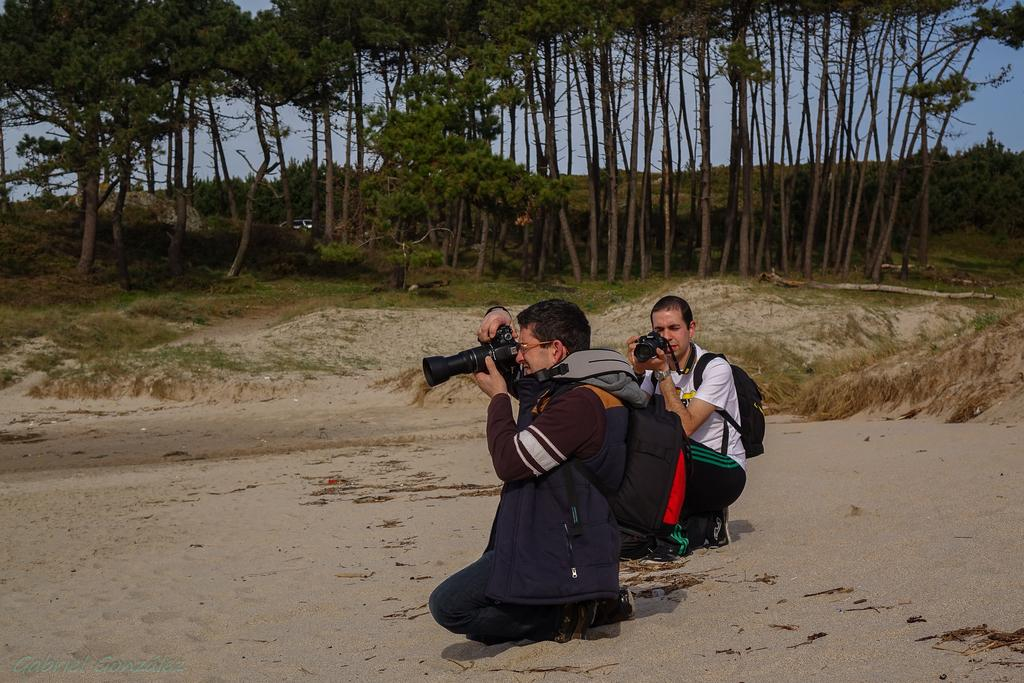How many people are in the image? There are two people in the image. What are the people doing in the image? The people are sitting on their knees. What are the people wearing in the image? The people are wearing bags. What are the people holding in their hands? The people are holding cameras in their hands. What can be seen in the background of the image? There are trees and the sky visible in the background of the image. Is there a cobweb visible on the trees in the background of the image? There is no mention of a cobweb in the image, so it cannot be determined if one is present. 